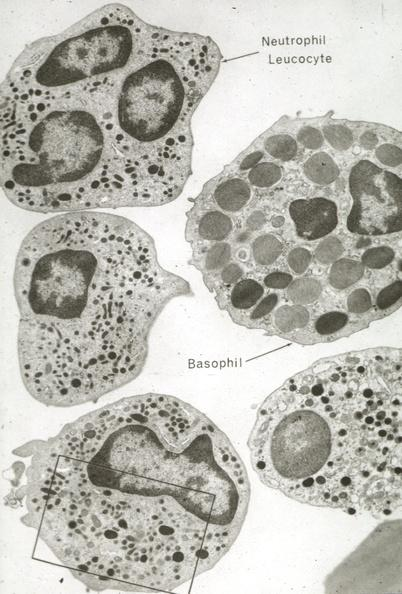s hematologic present?
Answer the question using a single word or phrase. Yes 